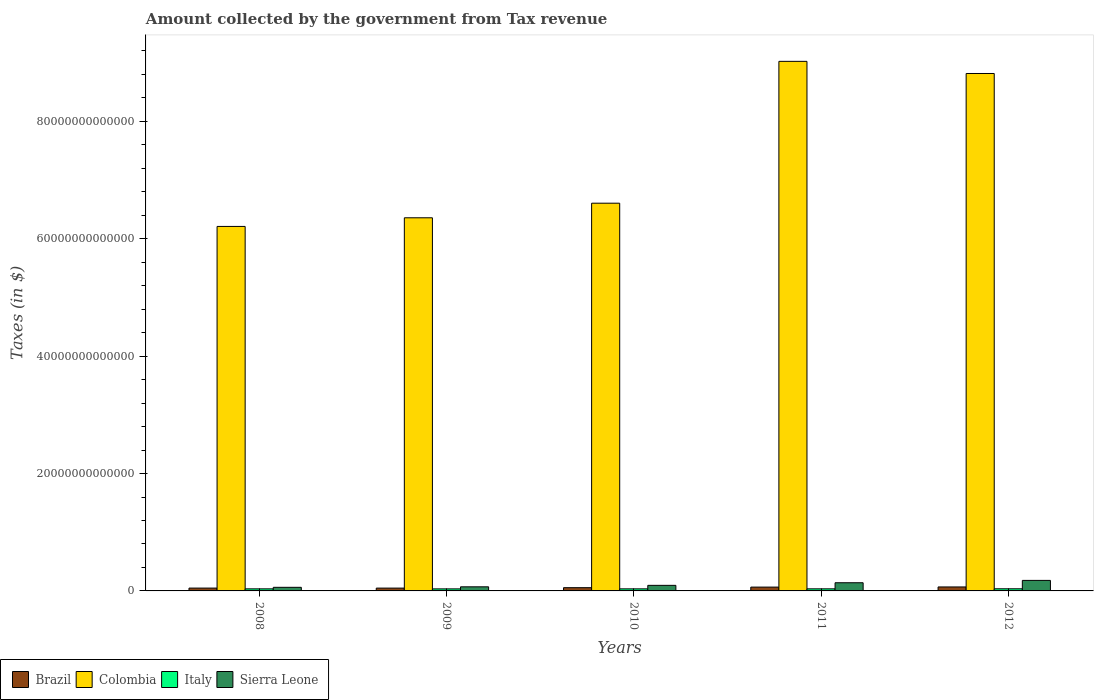How many different coloured bars are there?
Offer a very short reply. 4. Are the number of bars on each tick of the X-axis equal?
Offer a very short reply. Yes. How many bars are there on the 3rd tick from the left?
Your response must be concise. 4. How many bars are there on the 4th tick from the right?
Provide a short and direct response. 4. What is the label of the 1st group of bars from the left?
Your answer should be compact. 2008. In how many cases, is the number of bars for a given year not equal to the number of legend labels?
Provide a short and direct response. 0. What is the amount collected by the government from tax revenue in Brazil in 2008?
Your answer should be compact. 4.82e+11. Across all years, what is the maximum amount collected by the government from tax revenue in Colombia?
Offer a terse response. 9.02e+13. Across all years, what is the minimum amount collected by the government from tax revenue in Italy?
Make the answer very short. 3.48e+11. What is the total amount collected by the government from tax revenue in Colombia in the graph?
Provide a succinct answer. 3.70e+14. What is the difference between the amount collected by the government from tax revenue in Colombia in 2009 and that in 2011?
Keep it short and to the point. -2.67e+13. What is the difference between the amount collected by the government from tax revenue in Colombia in 2010 and the amount collected by the government from tax revenue in Italy in 2012?
Offer a terse response. 6.57e+13. What is the average amount collected by the government from tax revenue in Italy per year?
Provide a succinct answer. 3.54e+11. In the year 2008, what is the difference between the amount collected by the government from tax revenue in Italy and amount collected by the government from tax revenue in Colombia?
Ensure brevity in your answer.  -6.17e+13. In how many years, is the amount collected by the government from tax revenue in Colombia greater than 4000000000000 $?
Make the answer very short. 5. What is the ratio of the amount collected by the government from tax revenue in Brazil in 2009 to that in 2010?
Give a very brief answer. 0.87. What is the difference between the highest and the second highest amount collected by the government from tax revenue in Colombia?
Offer a terse response. 2.07e+12. What is the difference between the highest and the lowest amount collected by the government from tax revenue in Colombia?
Provide a short and direct response. 2.81e+13. What does the 4th bar from the left in 2011 represents?
Your response must be concise. Sierra Leone. What does the 2nd bar from the right in 2008 represents?
Your response must be concise. Italy. Is it the case that in every year, the sum of the amount collected by the government from tax revenue in Sierra Leone and amount collected by the government from tax revenue in Italy is greater than the amount collected by the government from tax revenue in Brazil?
Your answer should be compact. Yes. How many years are there in the graph?
Make the answer very short. 5. What is the difference between two consecutive major ticks on the Y-axis?
Your answer should be compact. 2.00e+13. Are the values on the major ticks of Y-axis written in scientific E-notation?
Give a very brief answer. No. Does the graph contain grids?
Offer a terse response. No. How many legend labels are there?
Offer a terse response. 4. What is the title of the graph?
Provide a succinct answer. Amount collected by the government from Tax revenue. Does "Iran" appear as one of the legend labels in the graph?
Your answer should be very brief. No. What is the label or title of the X-axis?
Give a very brief answer. Years. What is the label or title of the Y-axis?
Your answer should be very brief. Taxes (in $). What is the Taxes (in $) of Brazil in 2008?
Provide a succinct answer. 4.82e+11. What is the Taxes (in $) of Colombia in 2008?
Your answer should be very brief. 6.21e+13. What is the Taxes (in $) of Italy in 2008?
Make the answer very short. 3.53e+11. What is the Taxes (in $) of Sierra Leone in 2008?
Offer a very short reply. 6.13e+11. What is the Taxes (in $) in Brazil in 2009?
Offer a very short reply. 4.79e+11. What is the Taxes (in $) of Colombia in 2009?
Provide a short and direct response. 6.36e+13. What is the Taxes (in $) in Italy in 2009?
Offer a very short reply. 3.48e+11. What is the Taxes (in $) in Sierra Leone in 2009?
Your answer should be compact. 6.99e+11. What is the Taxes (in $) of Brazil in 2010?
Your answer should be compact. 5.52e+11. What is the Taxes (in $) of Colombia in 2010?
Make the answer very short. 6.61e+13. What is the Taxes (in $) of Italy in 2010?
Your answer should be very brief. 3.51e+11. What is the Taxes (in $) of Sierra Leone in 2010?
Offer a terse response. 9.48e+11. What is the Taxes (in $) in Brazil in 2011?
Ensure brevity in your answer.  6.52e+11. What is the Taxes (in $) of Colombia in 2011?
Offer a very short reply. 9.02e+13. What is the Taxes (in $) of Italy in 2011?
Provide a short and direct response. 3.55e+11. What is the Taxes (in $) in Sierra Leone in 2011?
Give a very brief answer. 1.39e+12. What is the Taxes (in $) in Brazil in 2012?
Provide a short and direct response. 6.77e+11. What is the Taxes (in $) in Colombia in 2012?
Offer a terse response. 8.82e+13. What is the Taxes (in $) of Italy in 2012?
Your response must be concise. 3.64e+11. What is the Taxes (in $) of Sierra Leone in 2012?
Provide a short and direct response. 1.79e+12. Across all years, what is the maximum Taxes (in $) in Brazil?
Provide a succinct answer. 6.77e+11. Across all years, what is the maximum Taxes (in $) of Colombia?
Make the answer very short. 9.02e+13. Across all years, what is the maximum Taxes (in $) of Italy?
Offer a terse response. 3.64e+11. Across all years, what is the maximum Taxes (in $) of Sierra Leone?
Your answer should be very brief. 1.79e+12. Across all years, what is the minimum Taxes (in $) of Brazil?
Your answer should be very brief. 4.79e+11. Across all years, what is the minimum Taxes (in $) in Colombia?
Keep it short and to the point. 6.21e+13. Across all years, what is the minimum Taxes (in $) in Italy?
Your answer should be very brief. 3.48e+11. Across all years, what is the minimum Taxes (in $) in Sierra Leone?
Provide a short and direct response. 6.13e+11. What is the total Taxes (in $) of Brazil in the graph?
Your response must be concise. 2.84e+12. What is the total Taxes (in $) of Colombia in the graph?
Provide a succinct answer. 3.70e+14. What is the total Taxes (in $) in Italy in the graph?
Keep it short and to the point. 1.77e+12. What is the total Taxes (in $) in Sierra Leone in the graph?
Your response must be concise. 5.45e+12. What is the difference between the Taxes (in $) in Brazil in 2008 and that in 2009?
Your answer should be compact. 2.91e+09. What is the difference between the Taxes (in $) of Colombia in 2008 and that in 2009?
Make the answer very short. -1.47e+12. What is the difference between the Taxes (in $) in Italy in 2008 and that in 2009?
Provide a succinct answer. 4.60e+09. What is the difference between the Taxes (in $) of Sierra Leone in 2008 and that in 2009?
Your response must be concise. -8.54e+1. What is the difference between the Taxes (in $) of Brazil in 2008 and that in 2010?
Ensure brevity in your answer.  -6.93e+1. What is the difference between the Taxes (in $) of Colombia in 2008 and that in 2010?
Offer a terse response. -3.96e+12. What is the difference between the Taxes (in $) in Italy in 2008 and that in 2010?
Offer a very short reply. 1.37e+09. What is the difference between the Taxes (in $) in Sierra Leone in 2008 and that in 2010?
Give a very brief answer. -3.35e+11. What is the difference between the Taxes (in $) of Brazil in 2008 and that in 2011?
Give a very brief answer. -1.70e+11. What is the difference between the Taxes (in $) of Colombia in 2008 and that in 2011?
Your answer should be compact. -2.81e+13. What is the difference between the Taxes (in $) in Italy in 2008 and that in 2011?
Your response must be concise. -1.77e+09. What is the difference between the Taxes (in $) of Sierra Leone in 2008 and that in 2011?
Offer a terse response. -7.80e+11. What is the difference between the Taxes (in $) in Brazil in 2008 and that in 2012?
Make the answer very short. -1.95e+11. What is the difference between the Taxes (in $) in Colombia in 2008 and that in 2012?
Give a very brief answer. -2.61e+13. What is the difference between the Taxes (in $) of Italy in 2008 and that in 2012?
Make the answer very short. -1.15e+1. What is the difference between the Taxes (in $) in Sierra Leone in 2008 and that in 2012?
Give a very brief answer. -1.18e+12. What is the difference between the Taxes (in $) in Brazil in 2009 and that in 2010?
Offer a very short reply. -7.22e+1. What is the difference between the Taxes (in $) of Colombia in 2009 and that in 2010?
Offer a very short reply. -2.49e+12. What is the difference between the Taxes (in $) in Italy in 2009 and that in 2010?
Make the answer very short. -3.24e+09. What is the difference between the Taxes (in $) in Sierra Leone in 2009 and that in 2010?
Give a very brief answer. -2.49e+11. What is the difference between the Taxes (in $) of Brazil in 2009 and that in 2011?
Provide a short and direct response. -1.73e+11. What is the difference between the Taxes (in $) in Colombia in 2009 and that in 2011?
Give a very brief answer. -2.67e+13. What is the difference between the Taxes (in $) in Italy in 2009 and that in 2011?
Provide a succinct answer. -6.37e+09. What is the difference between the Taxes (in $) of Sierra Leone in 2009 and that in 2011?
Ensure brevity in your answer.  -6.95e+11. What is the difference between the Taxes (in $) of Brazil in 2009 and that in 2012?
Your answer should be very brief. -1.98e+11. What is the difference between the Taxes (in $) in Colombia in 2009 and that in 2012?
Your answer should be compact. -2.46e+13. What is the difference between the Taxes (in $) of Italy in 2009 and that in 2012?
Your response must be concise. -1.61e+1. What is the difference between the Taxes (in $) in Sierra Leone in 2009 and that in 2012?
Give a very brief answer. -1.09e+12. What is the difference between the Taxes (in $) of Brazil in 2010 and that in 2011?
Keep it short and to the point. -1.00e+11. What is the difference between the Taxes (in $) of Colombia in 2010 and that in 2011?
Your response must be concise. -2.42e+13. What is the difference between the Taxes (in $) of Italy in 2010 and that in 2011?
Your response must be concise. -3.14e+09. What is the difference between the Taxes (in $) in Sierra Leone in 2010 and that in 2011?
Ensure brevity in your answer.  -4.45e+11. What is the difference between the Taxes (in $) of Brazil in 2010 and that in 2012?
Ensure brevity in your answer.  -1.26e+11. What is the difference between the Taxes (in $) in Colombia in 2010 and that in 2012?
Offer a terse response. -2.21e+13. What is the difference between the Taxes (in $) of Italy in 2010 and that in 2012?
Provide a short and direct response. -1.29e+1. What is the difference between the Taxes (in $) in Sierra Leone in 2010 and that in 2012?
Offer a very short reply. -8.45e+11. What is the difference between the Taxes (in $) of Brazil in 2011 and that in 2012?
Offer a very short reply. -2.53e+1. What is the difference between the Taxes (in $) of Colombia in 2011 and that in 2012?
Keep it short and to the point. 2.07e+12. What is the difference between the Taxes (in $) in Italy in 2011 and that in 2012?
Your answer should be very brief. -9.73e+09. What is the difference between the Taxes (in $) in Sierra Leone in 2011 and that in 2012?
Give a very brief answer. -4.00e+11. What is the difference between the Taxes (in $) in Brazil in 2008 and the Taxes (in $) in Colombia in 2009?
Give a very brief answer. -6.31e+13. What is the difference between the Taxes (in $) in Brazil in 2008 and the Taxes (in $) in Italy in 2009?
Make the answer very short. 1.34e+11. What is the difference between the Taxes (in $) of Brazil in 2008 and the Taxes (in $) of Sierra Leone in 2009?
Make the answer very short. -2.17e+11. What is the difference between the Taxes (in $) in Colombia in 2008 and the Taxes (in $) in Italy in 2009?
Offer a terse response. 6.18e+13. What is the difference between the Taxes (in $) in Colombia in 2008 and the Taxes (in $) in Sierra Leone in 2009?
Your answer should be compact. 6.14e+13. What is the difference between the Taxes (in $) in Italy in 2008 and the Taxes (in $) in Sierra Leone in 2009?
Make the answer very short. -3.46e+11. What is the difference between the Taxes (in $) in Brazil in 2008 and the Taxes (in $) in Colombia in 2010?
Your response must be concise. -6.56e+13. What is the difference between the Taxes (in $) in Brazil in 2008 and the Taxes (in $) in Italy in 2010?
Your response must be concise. 1.31e+11. What is the difference between the Taxes (in $) in Brazil in 2008 and the Taxes (in $) in Sierra Leone in 2010?
Keep it short and to the point. -4.66e+11. What is the difference between the Taxes (in $) in Colombia in 2008 and the Taxes (in $) in Italy in 2010?
Provide a succinct answer. 6.18e+13. What is the difference between the Taxes (in $) in Colombia in 2008 and the Taxes (in $) in Sierra Leone in 2010?
Your response must be concise. 6.12e+13. What is the difference between the Taxes (in $) in Italy in 2008 and the Taxes (in $) in Sierra Leone in 2010?
Provide a succinct answer. -5.96e+11. What is the difference between the Taxes (in $) of Brazil in 2008 and the Taxes (in $) of Colombia in 2011?
Ensure brevity in your answer.  -8.97e+13. What is the difference between the Taxes (in $) in Brazil in 2008 and the Taxes (in $) in Italy in 2011?
Give a very brief answer. 1.28e+11. What is the difference between the Taxes (in $) in Brazil in 2008 and the Taxes (in $) in Sierra Leone in 2011?
Your answer should be compact. -9.11e+11. What is the difference between the Taxes (in $) of Colombia in 2008 and the Taxes (in $) of Italy in 2011?
Your answer should be very brief. 6.17e+13. What is the difference between the Taxes (in $) in Colombia in 2008 and the Taxes (in $) in Sierra Leone in 2011?
Ensure brevity in your answer.  6.07e+13. What is the difference between the Taxes (in $) of Italy in 2008 and the Taxes (in $) of Sierra Leone in 2011?
Keep it short and to the point. -1.04e+12. What is the difference between the Taxes (in $) in Brazil in 2008 and the Taxes (in $) in Colombia in 2012?
Ensure brevity in your answer.  -8.77e+13. What is the difference between the Taxes (in $) of Brazil in 2008 and the Taxes (in $) of Italy in 2012?
Your response must be concise. 1.18e+11. What is the difference between the Taxes (in $) in Brazil in 2008 and the Taxes (in $) in Sierra Leone in 2012?
Provide a succinct answer. -1.31e+12. What is the difference between the Taxes (in $) of Colombia in 2008 and the Taxes (in $) of Italy in 2012?
Offer a terse response. 6.17e+13. What is the difference between the Taxes (in $) of Colombia in 2008 and the Taxes (in $) of Sierra Leone in 2012?
Your answer should be very brief. 6.03e+13. What is the difference between the Taxes (in $) of Italy in 2008 and the Taxes (in $) of Sierra Leone in 2012?
Provide a short and direct response. -1.44e+12. What is the difference between the Taxes (in $) in Brazil in 2009 and the Taxes (in $) in Colombia in 2010?
Provide a short and direct response. -6.56e+13. What is the difference between the Taxes (in $) in Brazil in 2009 and the Taxes (in $) in Italy in 2010?
Your answer should be compact. 1.28e+11. What is the difference between the Taxes (in $) of Brazil in 2009 and the Taxes (in $) of Sierra Leone in 2010?
Provide a short and direct response. -4.69e+11. What is the difference between the Taxes (in $) of Colombia in 2009 and the Taxes (in $) of Italy in 2010?
Ensure brevity in your answer.  6.32e+13. What is the difference between the Taxes (in $) in Colombia in 2009 and the Taxes (in $) in Sierra Leone in 2010?
Offer a very short reply. 6.26e+13. What is the difference between the Taxes (in $) in Italy in 2009 and the Taxes (in $) in Sierra Leone in 2010?
Make the answer very short. -6.00e+11. What is the difference between the Taxes (in $) of Brazil in 2009 and the Taxes (in $) of Colombia in 2011?
Provide a short and direct response. -8.97e+13. What is the difference between the Taxes (in $) of Brazil in 2009 and the Taxes (in $) of Italy in 2011?
Offer a very short reply. 1.25e+11. What is the difference between the Taxes (in $) of Brazil in 2009 and the Taxes (in $) of Sierra Leone in 2011?
Provide a short and direct response. -9.14e+11. What is the difference between the Taxes (in $) of Colombia in 2009 and the Taxes (in $) of Italy in 2011?
Provide a short and direct response. 6.32e+13. What is the difference between the Taxes (in $) in Colombia in 2009 and the Taxes (in $) in Sierra Leone in 2011?
Offer a very short reply. 6.22e+13. What is the difference between the Taxes (in $) in Italy in 2009 and the Taxes (in $) in Sierra Leone in 2011?
Your answer should be compact. -1.05e+12. What is the difference between the Taxes (in $) of Brazil in 2009 and the Taxes (in $) of Colombia in 2012?
Offer a terse response. -8.77e+13. What is the difference between the Taxes (in $) of Brazil in 2009 and the Taxes (in $) of Italy in 2012?
Keep it short and to the point. 1.15e+11. What is the difference between the Taxes (in $) of Brazil in 2009 and the Taxes (in $) of Sierra Leone in 2012?
Provide a succinct answer. -1.31e+12. What is the difference between the Taxes (in $) of Colombia in 2009 and the Taxes (in $) of Italy in 2012?
Provide a short and direct response. 6.32e+13. What is the difference between the Taxes (in $) of Colombia in 2009 and the Taxes (in $) of Sierra Leone in 2012?
Offer a terse response. 6.18e+13. What is the difference between the Taxes (in $) in Italy in 2009 and the Taxes (in $) in Sierra Leone in 2012?
Ensure brevity in your answer.  -1.45e+12. What is the difference between the Taxes (in $) of Brazil in 2010 and the Taxes (in $) of Colombia in 2011?
Your answer should be compact. -8.97e+13. What is the difference between the Taxes (in $) in Brazil in 2010 and the Taxes (in $) in Italy in 2011?
Provide a short and direct response. 1.97e+11. What is the difference between the Taxes (in $) in Brazil in 2010 and the Taxes (in $) in Sierra Leone in 2011?
Offer a terse response. -8.42e+11. What is the difference between the Taxes (in $) of Colombia in 2010 and the Taxes (in $) of Italy in 2011?
Offer a very short reply. 6.57e+13. What is the difference between the Taxes (in $) of Colombia in 2010 and the Taxes (in $) of Sierra Leone in 2011?
Keep it short and to the point. 6.47e+13. What is the difference between the Taxes (in $) in Italy in 2010 and the Taxes (in $) in Sierra Leone in 2011?
Ensure brevity in your answer.  -1.04e+12. What is the difference between the Taxes (in $) of Brazil in 2010 and the Taxes (in $) of Colombia in 2012?
Ensure brevity in your answer.  -8.76e+13. What is the difference between the Taxes (in $) of Brazil in 2010 and the Taxes (in $) of Italy in 2012?
Offer a terse response. 1.87e+11. What is the difference between the Taxes (in $) in Brazil in 2010 and the Taxes (in $) in Sierra Leone in 2012?
Your answer should be very brief. -1.24e+12. What is the difference between the Taxes (in $) of Colombia in 2010 and the Taxes (in $) of Italy in 2012?
Your answer should be compact. 6.57e+13. What is the difference between the Taxes (in $) in Colombia in 2010 and the Taxes (in $) in Sierra Leone in 2012?
Offer a terse response. 6.43e+13. What is the difference between the Taxes (in $) in Italy in 2010 and the Taxes (in $) in Sierra Leone in 2012?
Provide a short and direct response. -1.44e+12. What is the difference between the Taxes (in $) in Brazil in 2011 and the Taxes (in $) in Colombia in 2012?
Your response must be concise. -8.75e+13. What is the difference between the Taxes (in $) in Brazil in 2011 and the Taxes (in $) in Italy in 2012?
Provide a short and direct response. 2.88e+11. What is the difference between the Taxes (in $) of Brazil in 2011 and the Taxes (in $) of Sierra Leone in 2012?
Offer a terse response. -1.14e+12. What is the difference between the Taxes (in $) in Colombia in 2011 and the Taxes (in $) in Italy in 2012?
Provide a succinct answer. 8.99e+13. What is the difference between the Taxes (in $) in Colombia in 2011 and the Taxes (in $) in Sierra Leone in 2012?
Provide a succinct answer. 8.84e+13. What is the difference between the Taxes (in $) of Italy in 2011 and the Taxes (in $) of Sierra Leone in 2012?
Give a very brief answer. -1.44e+12. What is the average Taxes (in $) of Brazil per year?
Your response must be concise. 5.69e+11. What is the average Taxes (in $) in Colombia per year?
Provide a succinct answer. 7.40e+13. What is the average Taxes (in $) of Italy per year?
Your response must be concise. 3.54e+11. What is the average Taxes (in $) in Sierra Leone per year?
Your answer should be very brief. 1.09e+12. In the year 2008, what is the difference between the Taxes (in $) in Brazil and Taxes (in $) in Colombia?
Your response must be concise. -6.16e+13. In the year 2008, what is the difference between the Taxes (in $) in Brazil and Taxes (in $) in Italy?
Provide a short and direct response. 1.30e+11. In the year 2008, what is the difference between the Taxes (in $) in Brazil and Taxes (in $) in Sierra Leone?
Your answer should be compact. -1.31e+11. In the year 2008, what is the difference between the Taxes (in $) in Colombia and Taxes (in $) in Italy?
Ensure brevity in your answer.  6.17e+13. In the year 2008, what is the difference between the Taxes (in $) of Colombia and Taxes (in $) of Sierra Leone?
Your answer should be very brief. 6.15e+13. In the year 2008, what is the difference between the Taxes (in $) in Italy and Taxes (in $) in Sierra Leone?
Keep it short and to the point. -2.61e+11. In the year 2009, what is the difference between the Taxes (in $) in Brazil and Taxes (in $) in Colombia?
Provide a short and direct response. -6.31e+13. In the year 2009, what is the difference between the Taxes (in $) of Brazil and Taxes (in $) of Italy?
Offer a terse response. 1.31e+11. In the year 2009, what is the difference between the Taxes (in $) in Brazil and Taxes (in $) in Sierra Leone?
Give a very brief answer. -2.19e+11. In the year 2009, what is the difference between the Taxes (in $) of Colombia and Taxes (in $) of Italy?
Make the answer very short. 6.32e+13. In the year 2009, what is the difference between the Taxes (in $) in Colombia and Taxes (in $) in Sierra Leone?
Give a very brief answer. 6.29e+13. In the year 2009, what is the difference between the Taxes (in $) of Italy and Taxes (in $) of Sierra Leone?
Give a very brief answer. -3.51e+11. In the year 2010, what is the difference between the Taxes (in $) in Brazil and Taxes (in $) in Colombia?
Offer a very short reply. -6.55e+13. In the year 2010, what is the difference between the Taxes (in $) of Brazil and Taxes (in $) of Italy?
Give a very brief answer. 2.00e+11. In the year 2010, what is the difference between the Taxes (in $) of Brazil and Taxes (in $) of Sierra Leone?
Offer a very short reply. -3.97e+11. In the year 2010, what is the difference between the Taxes (in $) of Colombia and Taxes (in $) of Italy?
Keep it short and to the point. 6.57e+13. In the year 2010, what is the difference between the Taxes (in $) in Colombia and Taxes (in $) in Sierra Leone?
Offer a terse response. 6.51e+13. In the year 2010, what is the difference between the Taxes (in $) of Italy and Taxes (in $) of Sierra Leone?
Ensure brevity in your answer.  -5.97e+11. In the year 2011, what is the difference between the Taxes (in $) in Brazil and Taxes (in $) in Colombia?
Offer a terse response. -8.96e+13. In the year 2011, what is the difference between the Taxes (in $) in Brazil and Taxes (in $) in Italy?
Your answer should be very brief. 2.98e+11. In the year 2011, what is the difference between the Taxes (in $) of Brazil and Taxes (in $) of Sierra Leone?
Offer a very short reply. -7.42e+11. In the year 2011, what is the difference between the Taxes (in $) of Colombia and Taxes (in $) of Italy?
Give a very brief answer. 8.99e+13. In the year 2011, what is the difference between the Taxes (in $) in Colombia and Taxes (in $) in Sierra Leone?
Ensure brevity in your answer.  8.88e+13. In the year 2011, what is the difference between the Taxes (in $) of Italy and Taxes (in $) of Sierra Leone?
Provide a short and direct response. -1.04e+12. In the year 2012, what is the difference between the Taxes (in $) in Brazil and Taxes (in $) in Colombia?
Your answer should be compact. -8.75e+13. In the year 2012, what is the difference between the Taxes (in $) of Brazil and Taxes (in $) of Italy?
Your answer should be very brief. 3.13e+11. In the year 2012, what is the difference between the Taxes (in $) of Brazil and Taxes (in $) of Sierra Leone?
Give a very brief answer. -1.12e+12. In the year 2012, what is the difference between the Taxes (in $) of Colombia and Taxes (in $) of Italy?
Provide a short and direct response. 8.78e+13. In the year 2012, what is the difference between the Taxes (in $) in Colombia and Taxes (in $) in Sierra Leone?
Provide a succinct answer. 8.64e+13. In the year 2012, what is the difference between the Taxes (in $) of Italy and Taxes (in $) of Sierra Leone?
Your answer should be compact. -1.43e+12. What is the ratio of the Taxes (in $) in Colombia in 2008 to that in 2009?
Provide a succinct answer. 0.98. What is the ratio of the Taxes (in $) of Italy in 2008 to that in 2009?
Your answer should be very brief. 1.01. What is the ratio of the Taxes (in $) in Sierra Leone in 2008 to that in 2009?
Your answer should be very brief. 0.88. What is the ratio of the Taxes (in $) in Brazil in 2008 to that in 2010?
Offer a terse response. 0.87. What is the ratio of the Taxes (in $) of Colombia in 2008 to that in 2010?
Your response must be concise. 0.94. What is the ratio of the Taxes (in $) in Sierra Leone in 2008 to that in 2010?
Your response must be concise. 0.65. What is the ratio of the Taxes (in $) in Brazil in 2008 to that in 2011?
Offer a very short reply. 0.74. What is the ratio of the Taxes (in $) of Colombia in 2008 to that in 2011?
Offer a very short reply. 0.69. What is the ratio of the Taxes (in $) in Italy in 2008 to that in 2011?
Provide a short and direct response. 0.99. What is the ratio of the Taxes (in $) of Sierra Leone in 2008 to that in 2011?
Your answer should be compact. 0.44. What is the ratio of the Taxes (in $) in Brazil in 2008 to that in 2012?
Make the answer very short. 0.71. What is the ratio of the Taxes (in $) in Colombia in 2008 to that in 2012?
Make the answer very short. 0.7. What is the ratio of the Taxes (in $) of Italy in 2008 to that in 2012?
Keep it short and to the point. 0.97. What is the ratio of the Taxes (in $) in Sierra Leone in 2008 to that in 2012?
Make the answer very short. 0.34. What is the ratio of the Taxes (in $) in Brazil in 2009 to that in 2010?
Make the answer very short. 0.87. What is the ratio of the Taxes (in $) of Colombia in 2009 to that in 2010?
Give a very brief answer. 0.96. What is the ratio of the Taxes (in $) of Italy in 2009 to that in 2010?
Your response must be concise. 0.99. What is the ratio of the Taxes (in $) of Sierra Leone in 2009 to that in 2010?
Give a very brief answer. 0.74. What is the ratio of the Taxes (in $) in Brazil in 2009 to that in 2011?
Provide a succinct answer. 0.74. What is the ratio of the Taxes (in $) in Colombia in 2009 to that in 2011?
Offer a very short reply. 0.7. What is the ratio of the Taxes (in $) in Sierra Leone in 2009 to that in 2011?
Ensure brevity in your answer.  0.5. What is the ratio of the Taxes (in $) in Brazil in 2009 to that in 2012?
Provide a short and direct response. 0.71. What is the ratio of the Taxes (in $) in Colombia in 2009 to that in 2012?
Provide a short and direct response. 0.72. What is the ratio of the Taxes (in $) of Italy in 2009 to that in 2012?
Give a very brief answer. 0.96. What is the ratio of the Taxes (in $) of Sierra Leone in 2009 to that in 2012?
Provide a succinct answer. 0.39. What is the ratio of the Taxes (in $) of Brazil in 2010 to that in 2011?
Give a very brief answer. 0.85. What is the ratio of the Taxes (in $) of Colombia in 2010 to that in 2011?
Offer a terse response. 0.73. What is the ratio of the Taxes (in $) in Sierra Leone in 2010 to that in 2011?
Keep it short and to the point. 0.68. What is the ratio of the Taxes (in $) in Brazil in 2010 to that in 2012?
Make the answer very short. 0.81. What is the ratio of the Taxes (in $) in Colombia in 2010 to that in 2012?
Offer a terse response. 0.75. What is the ratio of the Taxes (in $) of Italy in 2010 to that in 2012?
Provide a succinct answer. 0.96. What is the ratio of the Taxes (in $) in Sierra Leone in 2010 to that in 2012?
Your answer should be very brief. 0.53. What is the ratio of the Taxes (in $) of Brazil in 2011 to that in 2012?
Provide a short and direct response. 0.96. What is the ratio of the Taxes (in $) of Colombia in 2011 to that in 2012?
Give a very brief answer. 1.02. What is the ratio of the Taxes (in $) of Italy in 2011 to that in 2012?
Your answer should be very brief. 0.97. What is the ratio of the Taxes (in $) of Sierra Leone in 2011 to that in 2012?
Offer a terse response. 0.78. What is the difference between the highest and the second highest Taxes (in $) in Brazil?
Ensure brevity in your answer.  2.53e+1. What is the difference between the highest and the second highest Taxes (in $) in Colombia?
Give a very brief answer. 2.07e+12. What is the difference between the highest and the second highest Taxes (in $) in Italy?
Your answer should be very brief. 9.73e+09. What is the difference between the highest and the second highest Taxes (in $) in Sierra Leone?
Offer a terse response. 4.00e+11. What is the difference between the highest and the lowest Taxes (in $) in Brazil?
Offer a terse response. 1.98e+11. What is the difference between the highest and the lowest Taxes (in $) of Colombia?
Make the answer very short. 2.81e+13. What is the difference between the highest and the lowest Taxes (in $) of Italy?
Offer a very short reply. 1.61e+1. What is the difference between the highest and the lowest Taxes (in $) of Sierra Leone?
Your answer should be compact. 1.18e+12. 